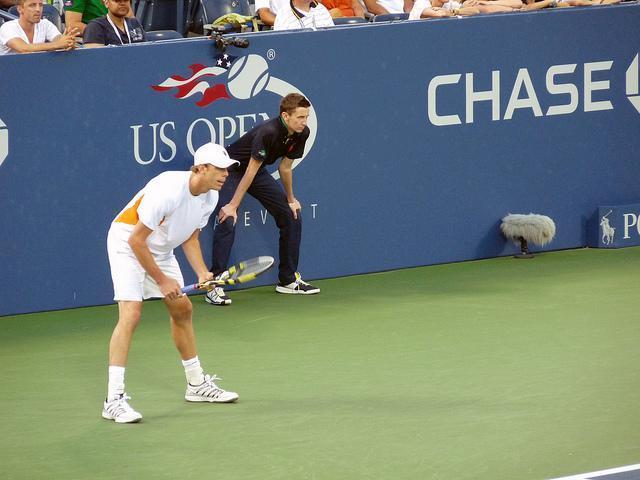How many people can you see?
Give a very brief answer. 3. How many elephants are there?
Give a very brief answer. 0. 